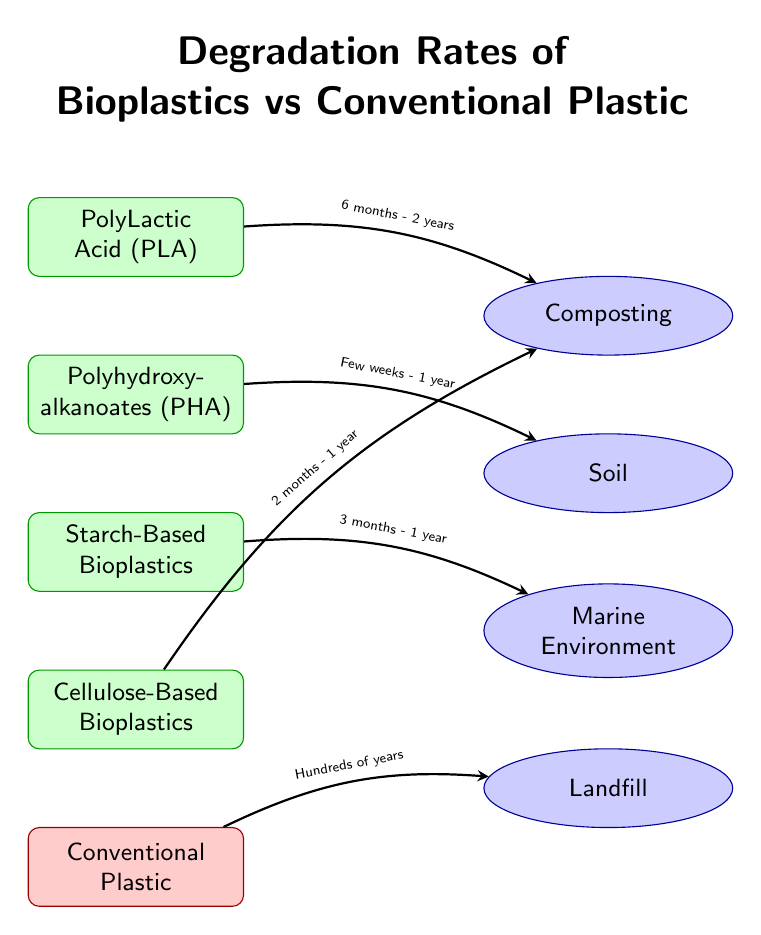What is the degradation time range for PolyLactic Acid (PLA) in composting? The diagram indicates the degradation time for PLA moving towards the composting environment is between 6 months and 2 years. This information is shown directly on the arrow leading from the PLA node to the composting node.
Answer: 6 months - 2 years Which conventional plastic is shown to degrade in hundreds of years? The diagram includes a node for Conventional Plastic, which has an arrow leading to the landfill environment, labeled with the time frame of "Hundreds of years". This specific detail identifies that conventional plastic degrades very slowly compared to bioplastics.
Answer: Conventional Plastic How many bioplastic types are listed in the diagram? By counting the bioplastic nodes (PLA, PHA, Starch-Based Bioplastics, and Cellulose-Based Bioplastics), the total can be derived. There are four distinct bioplastic types represented in the diagram overall.
Answer: 4 What environment is associated with the fastest degradation of Polyhydroxy-alkanoates (PHA)? In the diagram, PHA has an arrow pointing towards the soil environment, which is stated to have a degradation time of "Few weeks - 1 year". This indicates that this environment leads to the quickest degradation for PHA.
Answer: Soil Which bioplastic has the shortest degradation time in the marine environment? Upon examining the diagram, Starch-Based Bioplastics are linked to the marine environment with a degradation time listed as "3 months - 1 year". This shows that this type of bioplastic degrades more quickly in the marine setting than others.
Answer: Starch-Based Bioplastics 